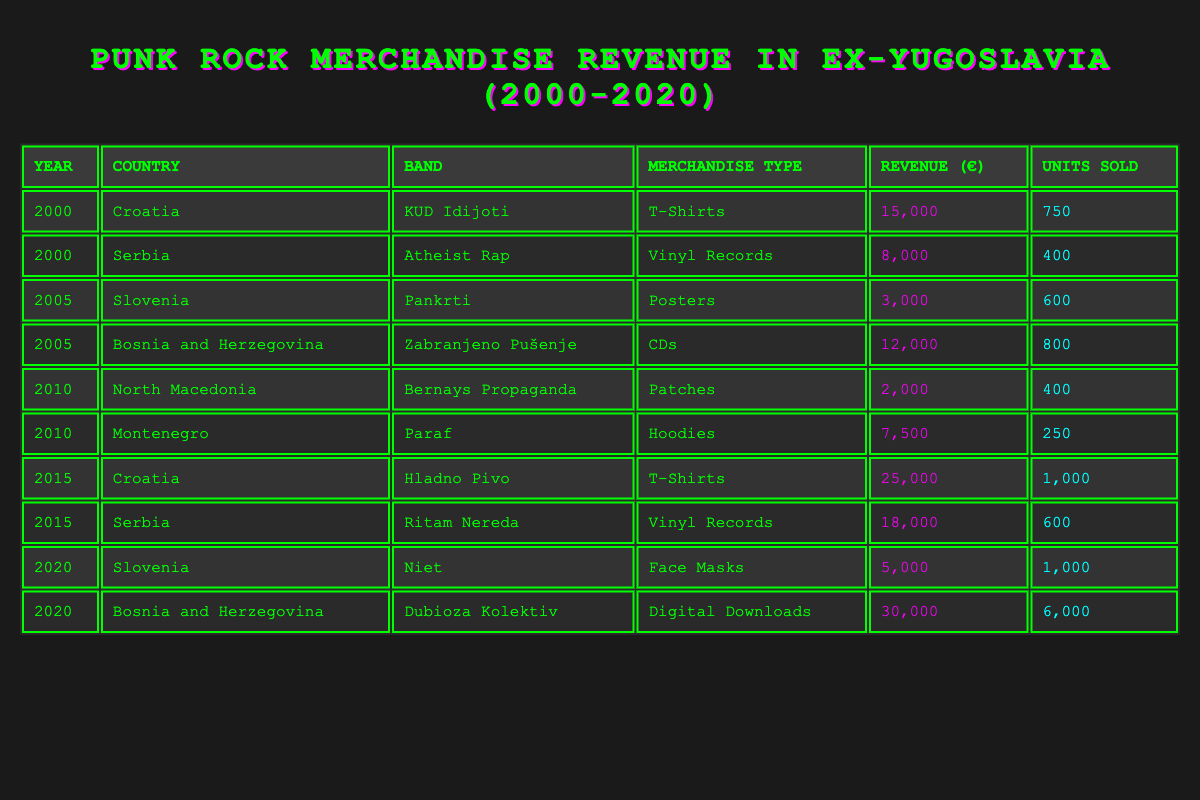What is the total merchandise revenue from Croatia in 2015? In 2015, there are two entries from Croatia: "Hladno Pivo" with a revenue of 25,000 and from 2000, "KUD Idijoti" with 15,000. The total revenue is 25,000 + 15,000 = 40,000.
Answer: 40,000 Which band had the highest revenue in 2020? In 2020, there are two entries: "Niet" from Slovenia with a revenue of 5,000 and "Dubioza Kolektiv" from Bosnia and Herzegovina with a revenue of 30,000. "Dubioza Kolektiv" has the highest revenue at 30,000.
Answer: Dubioza Kolektiv How many units of merchandise were sold by "Ritam Nereda" in 2015? Referring to the table, "Ritam Nereda" from Serbia has a revenue of 18,000 with units sold recorded as 600. Thus, 600 units were sold.
Answer: 600 What was the average revenue of merchandise sold by bands from Bosnia and Herzegovina from 2005 to 2020? From the provided data, in 2005 revenue is 12,000 from "Zabranjeno Pušenje," and in 2020, it is 30,000 from "Dubioza Kolektiv." The average is calculated as (12,000 + 30,000) / 2 = 21,000.
Answer: 21,000 Did any band from North Macedonia sell more merchandise than "Bernays Propaganda" in 2010? The table shows "Bernays Propaganda" had a revenue of 2,000 with 400 units sold. There are no other entries from North Macedonia in 2010, making it impossible for any other band from North Macedonia to have sold more in that year.
Answer: No How much total revenue was earned from T-Shirts and Vinyl Records across all years? The table shows "KUD Idijoti" with 15,000 (T-Shirts in 2000) and "Hladno Pivo" with 25,000 (T-Shirts in 2015), along with "Atheist Rap" with 8,000 (Vinyl Records in 2000) and "Ritam Nereda" with 18,000 (Vinyl Records in 2015). Total revenue from T-Shirts is 15,000 + 25,000 = 40,000, and from Vinyl Records is 8,000 + 18,000 = 26,000. So total revenue = 40,000 + 26,000 = 66,000.
Answer: 66,000 What is the total number of units sold for merchandise in 2020 across both countries shown? The table indicates in 2020, "Niet" sold 1,000 units and "Dubioza Kolektiv" sold 6,000 units. Thus, the total number of units sold is 1,000 + 6,000 = 7,000 units.
Answer: 7,000 Which country generated more revenue, Bosnia and Herzegovina or Serbia, in 2015? For Bosnia and Herzegovina, the revenue from "Zabranjeno Pušenje" in 2005 is 12,000, and for Serbia from "Ritam Nereda" in 2015 is 18,000. Comparing the two, Serbia had a higher revenue than Bosnia and Herzegovina.
Answer: Serbia What was the percentage increase in revenue for "Hladno Pivo" from 2000 to 2015? "Hladno Pivo" earned 15,000 in 2000 and 25,000 in 2015. The increase is 25,000 - 15,000 = 10,000. To find the percentage increase: (10,000 / 15,000) * 100 = 66.67%.
Answer: 66.67% 